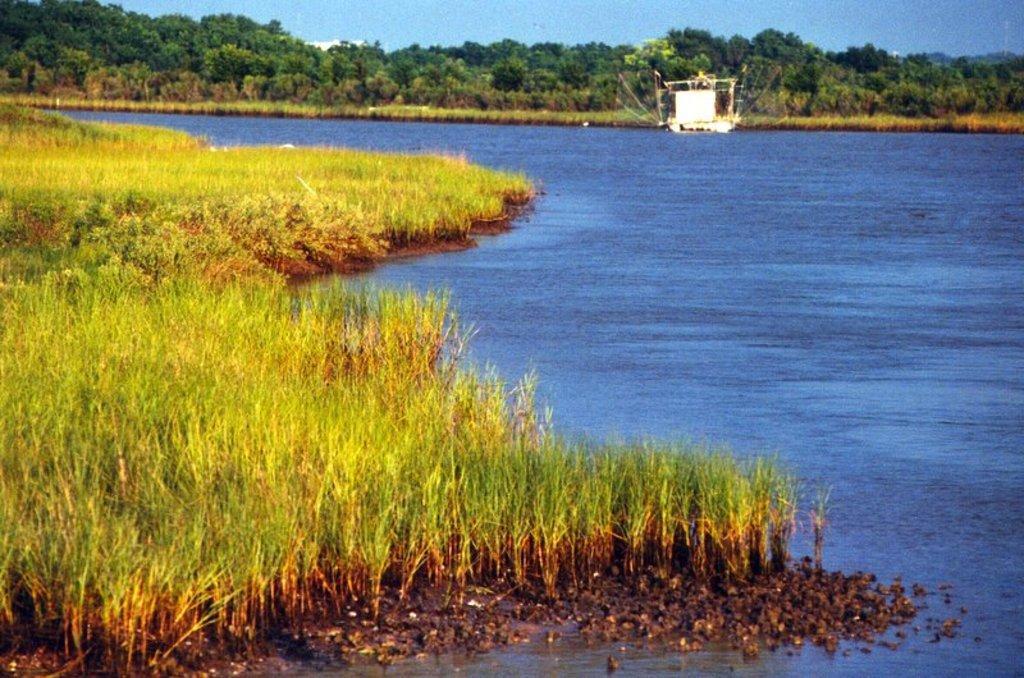Please provide a concise description of this image. In this image we can see grass, water. In the background of the image there are trees, sky. 